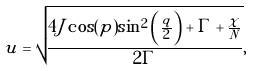Convert formula to latex. <formula><loc_0><loc_0><loc_500><loc_500>u = \sqrt { \frac { 4 J \cos ( p ) \sin ^ { 2 } \left ( \frac { q } { 2 } \right ) + \Gamma + \frac { \chi } { N } } { 2 \Gamma } } ,</formula> 